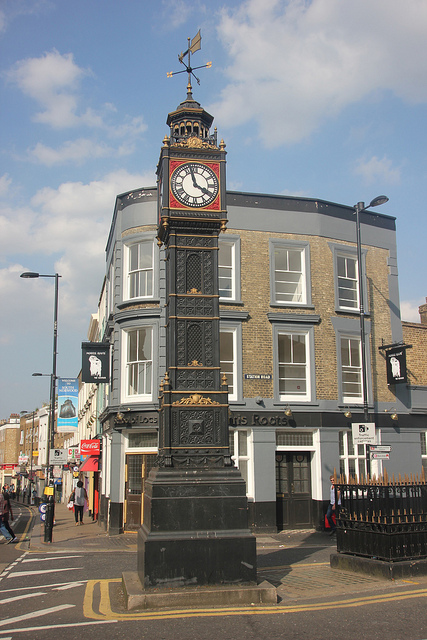This street is located where? This street, featuring a prominent clock tower and urban surroundings, is located in a city. The architecture and busy street life suggest a setting within an urban environment. 